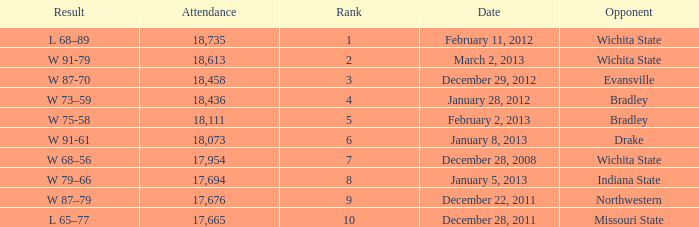Could you help me parse every detail presented in this table? {'header': ['Result', 'Attendance', 'Rank', 'Date', 'Opponent'], 'rows': [['L 68–89', '18,735', '1', 'February 11, 2012', 'Wichita State'], ['W 91-79', '18,613', '2', 'March 2, 2013', 'Wichita State'], ['W 87-70', '18,458', '3', 'December 29, 2012', 'Evansville'], ['W 73–59', '18,436', '4', 'January 28, 2012', 'Bradley'], ['W 75-58', '18,111', '5', 'February 2, 2013', 'Bradley'], ['W 91-61', '18,073', '6', 'January 8, 2013', 'Drake'], ['W 68–56', '17,954', '7', 'December 28, 2008', 'Wichita State'], ['W 79–66', '17,694', '8', 'January 5, 2013', 'Indiana State'], ['W 87–79', '17,676', '9', 'December 22, 2011', 'Northwestern'], ['L 65–77', '17,665', '10', 'December 28, 2011', 'Missouri State']]} What's the rank for February 11, 2012 with less than 18,735 in attendance? None. 